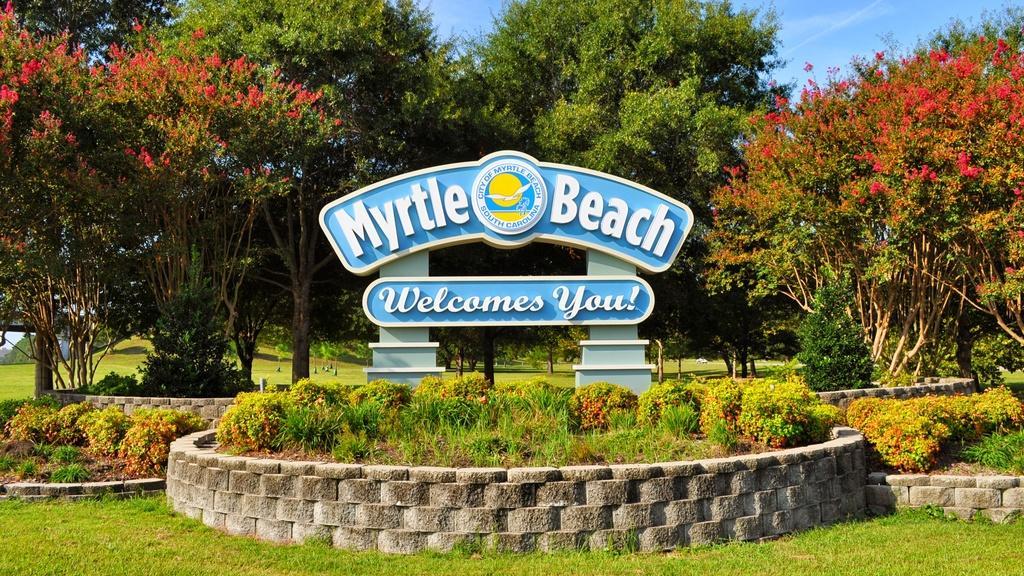Can you describe this image briefly? In this image there is a name board, there are few trees, garden plants, grass, small walls and the sky. 